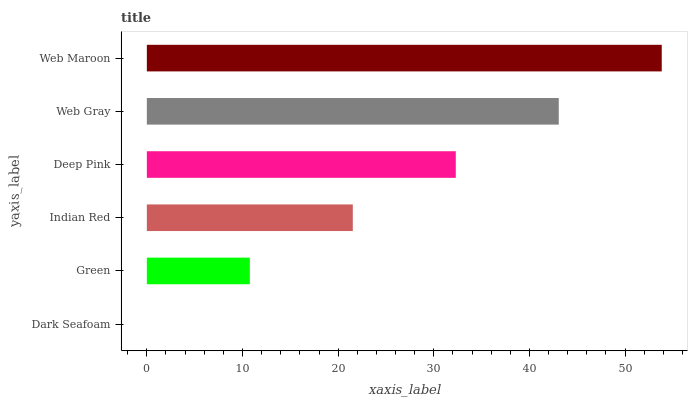Is Dark Seafoam the minimum?
Answer yes or no. Yes. Is Web Maroon the maximum?
Answer yes or no. Yes. Is Green the minimum?
Answer yes or no. No. Is Green the maximum?
Answer yes or no. No. Is Green greater than Dark Seafoam?
Answer yes or no. Yes. Is Dark Seafoam less than Green?
Answer yes or no. Yes. Is Dark Seafoam greater than Green?
Answer yes or no. No. Is Green less than Dark Seafoam?
Answer yes or no. No. Is Deep Pink the high median?
Answer yes or no. Yes. Is Indian Red the low median?
Answer yes or no. Yes. Is Green the high median?
Answer yes or no. No. Is Green the low median?
Answer yes or no. No. 